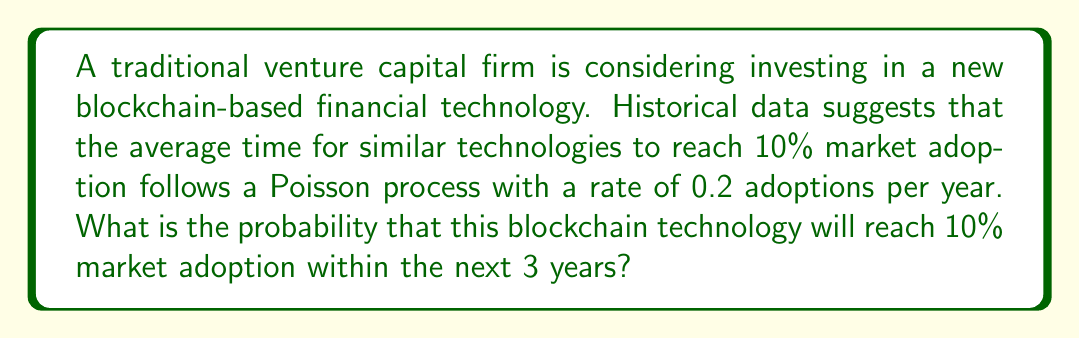Can you solve this math problem? Let's approach this step-by-step:

1) The Poisson process models the number of events in a given time interval. In this case, we're interested in the time until the first event (10% market adoption).

2) For a Poisson process, the time until the first event follows an exponential distribution with the same rate parameter λ as the Poisson process.

3) Given:
   - Rate of adoption: λ = 0.2 per year
   - Time period: t = 3 years

4) We need to find P(T ≤ 3), where T is the time to 10% adoption.

5) For an exponential distribution:
   P(T ≤ t) = 1 - e^(-λt)

6) Substituting our values:
   P(T ≤ 3) = 1 - e^(-0.2 * 3)
            = 1 - e^(-0.6)

7) Calculating:
   e^(-0.6) ≈ 0.5488

8) Therefore:
   P(T ≤ 3) = 1 - 0.5488 ≈ 0.4512

9) Converting to a percentage:
   0.4512 * 100% ≈ 45.12%
Answer: 45.12% 